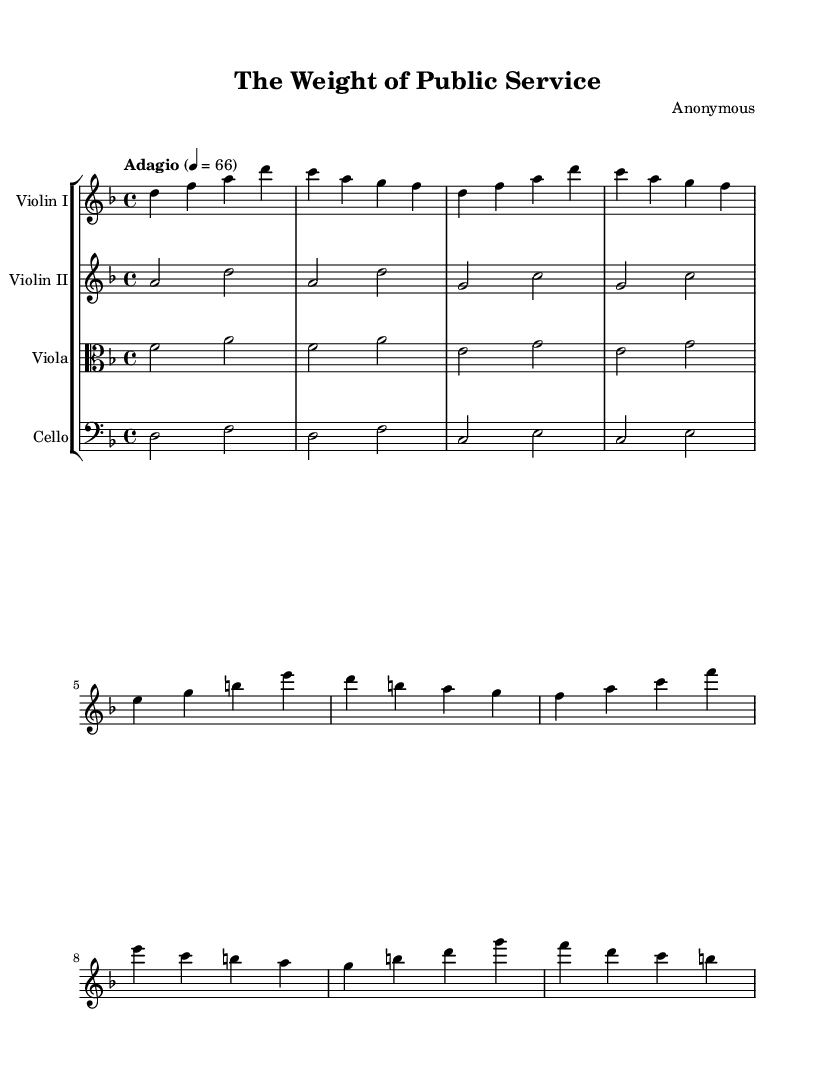What is the key signature of this music? The key signature is D minor, as indicated by one flat (B flat) in the key signature at the beginning of the staff.
Answer: D minor What is the time signature of this piece? The time signature is 4/4, which is displayed at the beginning of the staff indicating there are four beats per measure with a quarter note receiving one beat.
Answer: 4/4 What is the tempo marking for this piece? The tempo marking is "Adagio," which suggests a slow and reflective pace, often associated with a tempo range of 66 beats per minute.
Answer: Adagio How many instruments are included in the score? There are four instruments included: Violin I, Violin II, Viola, and Cello, as shown in the staff group at the beginning of the score.
Answer: Four Which instrument plays the main theme? The main theme is played by Violin I, as indicated by the first staff in the score which contains the melody line.
Answer: Violin I What form of music structure is presented in this Symphony? The music presents a thematic structure with clear sections labeled as Theme A and Theme B, typically found in symphonic compositions.
Answer: Thematic structure What type of musical dynamics might you expect from the tempo marking and instrumentation? Given the adagio tempo and the instrumentation, one might expect softer dynamics, possibly marked as piano or mezzo-piano throughout the piece, enhancing the contemplative nature of public service themes.
Answer: Soft dynamics 